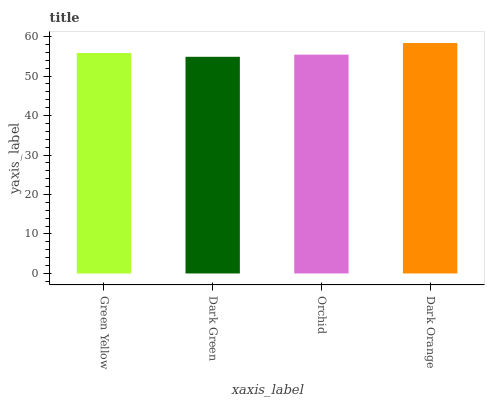Is Orchid the minimum?
Answer yes or no. No. Is Orchid the maximum?
Answer yes or no. No. Is Orchid greater than Dark Green?
Answer yes or no. Yes. Is Dark Green less than Orchid?
Answer yes or no. Yes. Is Dark Green greater than Orchid?
Answer yes or no. No. Is Orchid less than Dark Green?
Answer yes or no. No. Is Green Yellow the high median?
Answer yes or no. Yes. Is Orchid the low median?
Answer yes or no. Yes. Is Dark Orange the high median?
Answer yes or no. No. Is Green Yellow the low median?
Answer yes or no. No. 